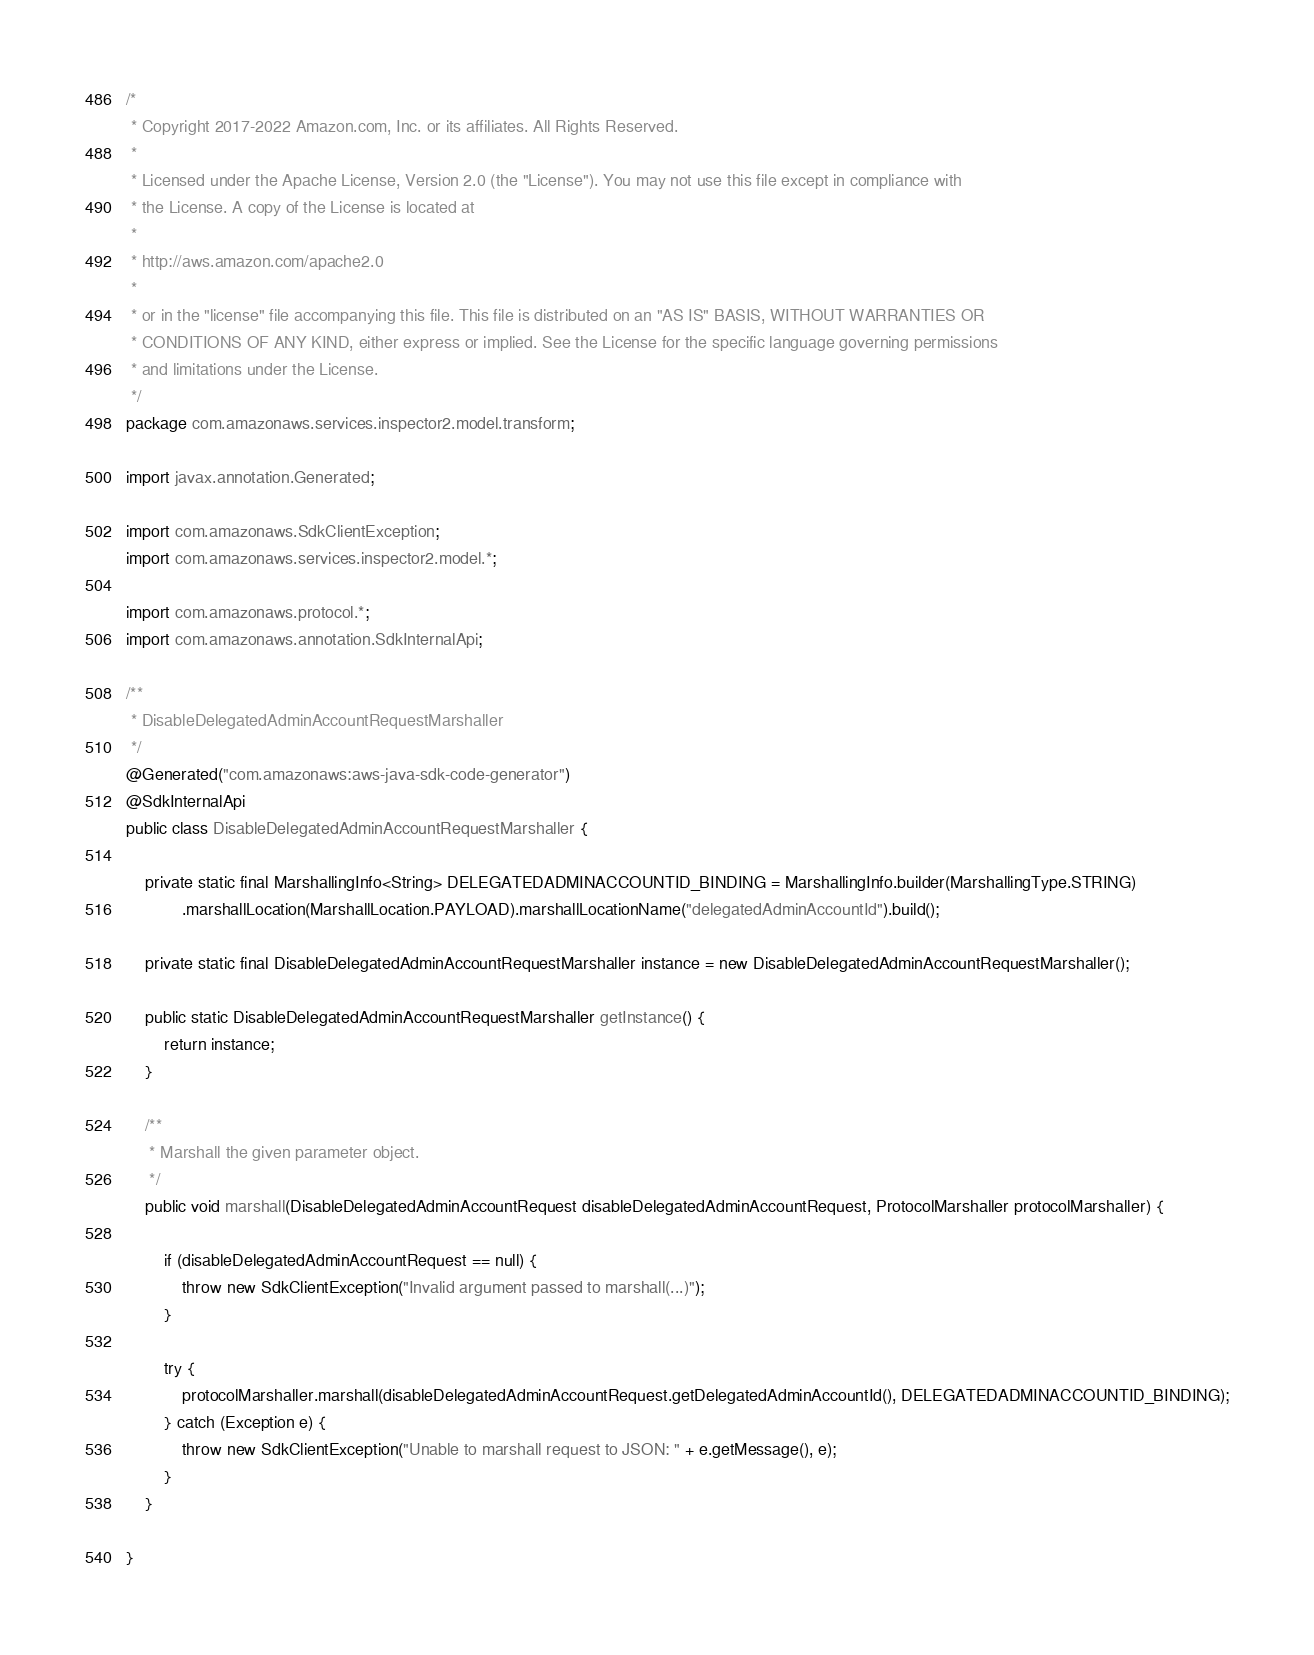<code> <loc_0><loc_0><loc_500><loc_500><_Java_>/*
 * Copyright 2017-2022 Amazon.com, Inc. or its affiliates. All Rights Reserved.
 * 
 * Licensed under the Apache License, Version 2.0 (the "License"). You may not use this file except in compliance with
 * the License. A copy of the License is located at
 * 
 * http://aws.amazon.com/apache2.0
 * 
 * or in the "license" file accompanying this file. This file is distributed on an "AS IS" BASIS, WITHOUT WARRANTIES OR
 * CONDITIONS OF ANY KIND, either express or implied. See the License for the specific language governing permissions
 * and limitations under the License.
 */
package com.amazonaws.services.inspector2.model.transform;

import javax.annotation.Generated;

import com.amazonaws.SdkClientException;
import com.amazonaws.services.inspector2.model.*;

import com.amazonaws.protocol.*;
import com.amazonaws.annotation.SdkInternalApi;

/**
 * DisableDelegatedAdminAccountRequestMarshaller
 */
@Generated("com.amazonaws:aws-java-sdk-code-generator")
@SdkInternalApi
public class DisableDelegatedAdminAccountRequestMarshaller {

    private static final MarshallingInfo<String> DELEGATEDADMINACCOUNTID_BINDING = MarshallingInfo.builder(MarshallingType.STRING)
            .marshallLocation(MarshallLocation.PAYLOAD).marshallLocationName("delegatedAdminAccountId").build();

    private static final DisableDelegatedAdminAccountRequestMarshaller instance = new DisableDelegatedAdminAccountRequestMarshaller();

    public static DisableDelegatedAdminAccountRequestMarshaller getInstance() {
        return instance;
    }

    /**
     * Marshall the given parameter object.
     */
    public void marshall(DisableDelegatedAdminAccountRequest disableDelegatedAdminAccountRequest, ProtocolMarshaller protocolMarshaller) {

        if (disableDelegatedAdminAccountRequest == null) {
            throw new SdkClientException("Invalid argument passed to marshall(...)");
        }

        try {
            protocolMarshaller.marshall(disableDelegatedAdminAccountRequest.getDelegatedAdminAccountId(), DELEGATEDADMINACCOUNTID_BINDING);
        } catch (Exception e) {
            throw new SdkClientException("Unable to marshall request to JSON: " + e.getMessage(), e);
        }
    }

}
</code> 